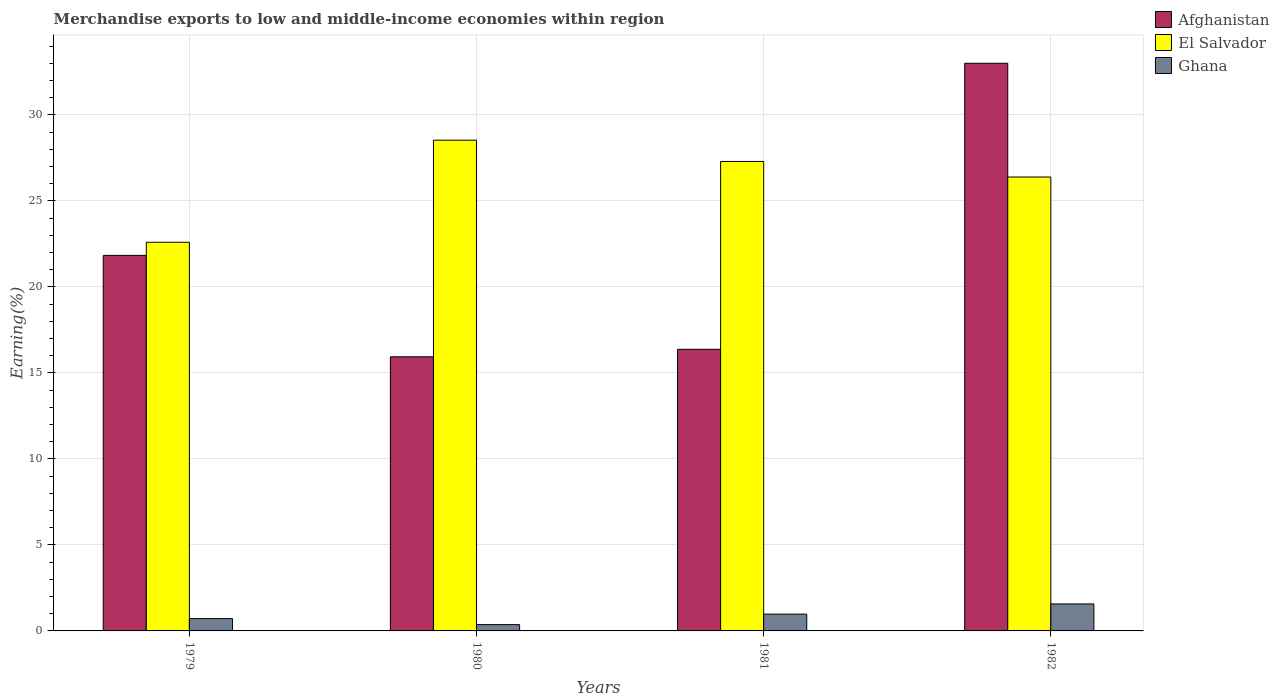Are the number of bars on each tick of the X-axis equal?
Ensure brevity in your answer.  Yes. How many bars are there on the 1st tick from the left?
Provide a succinct answer. 3. How many bars are there on the 4th tick from the right?
Your response must be concise. 3. What is the label of the 1st group of bars from the left?
Keep it short and to the point. 1979. In how many cases, is the number of bars for a given year not equal to the number of legend labels?
Your answer should be compact. 0. What is the percentage of amount earned from merchandise exports in Afghanistan in 1979?
Keep it short and to the point. 21.83. Across all years, what is the maximum percentage of amount earned from merchandise exports in El Salvador?
Make the answer very short. 28.53. Across all years, what is the minimum percentage of amount earned from merchandise exports in El Salvador?
Offer a very short reply. 22.59. In which year was the percentage of amount earned from merchandise exports in Afghanistan minimum?
Your answer should be compact. 1980. What is the total percentage of amount earned from merchandise exports in El Salvador in the graph?
Your answer should be very brief. 104.8. What is the difference between the percentage of amount earned from merchandise exports in Afghanistan in 1980 and that in 1981?
Give a very brief answer. -0.43. What is the difference between the percentage of amount earned from merchandise exports in El Salvador in 1981 and the percentage of amount earned from merchandise exports in Ghana in 1980?
Provide a succinct answer. 26.92. What is the average percentage of amount earned from merchandise exports in Ghana per year?
Offer a terse response. 0.91. In the year 1979, what is the difference between the percentage of amount earned from merchandise exports in El Salvador and percentage of amount earned from merchandise exports in Afghanistan?
Provide a short and direct response. 0.76. What is the ratio of the percentage of amount earned from merchandise exports in Ghana in 1980 to that in 1981?
Your answer should be compact. 0.38. Is the percentage of amount earned from merchandise exports in Afghanistan in 1979 less than that in 1980?
Your answer should be compact. No. What is the difference between the highest and the second highest percentage of amount earned from merchandise exports in El Salvador?
Your answer should be very brief. 1.24. What is the difference between the highest and the lowest percentage of amount earned from merchandise exports in Afghanistan?
Your answer should be very brief. 17.06. In how many years, is the percentage of amount earned from merchandise exports in Ghana greater than the average percentage of amount earned from merchandise exports in Ghana taken over all years?
Make the answer very short. 2. Is the sum of the percentage of amount earned from merchandise exports in Afghanistan in 1980 and 1982 greater than the maximum percentage of amount earned from merchandise exports in Ghana across all years?
Your answer should be very brief. Yes. What does the 2nd bar from the left in 1980 represents?
Ensure brevity in your answer.  El Salvador. What does the 3rd bar from the right in 1981 represents?
Your response must be concise. Afghanistan. What is the difference between two consecutive major ticks on the Y-axis?
Make the answer very short. 5. Does the graph contain any zero values?
Keep it short and to the point. No. Does the graph contain grids?
Give a very brief answer. Yes. How many legend labels are there?
Your response must be concise. 3. How are the legend labels stacked?
Your response must be concise. Vertical. What is the title of the graph?
Keep it short and to the point. Merchandise exports to low and middle-income economies within region. What is the label or title of the Y-axis?
Give a very brief answer. Earning(%). What is the Earning(%) of Afghanistan in 1979?
Offer a terse response. 21.83. What is the Earning(%) of El Salvador in 1979?
Provide a short and direct response. 22.59. What is the Earning(%) in Ghana in 1979?
Offer a very short reply. 0.72. What is the Earning(%) in Afghanistan in 1980?
Your answer should be compact. 15.94. What is the Earning(%) of El Salvador in 1980?
Make the answer very short. 28.53. What is the Earning(%) in Ghana in 1980?
Give a very brief answer. 0.37. What is the Earning(%) in Afghanistan in 1981?
Keep it short and to the point. 16.37. What is the Earning(%) in El Salvador in 1981?
Your answer should be very brief. 27.29. What is the Earning(%) of Ghana in 1981?
Ensure brevity in your answer.  0.98. What is the Earning(%) of Afghanistan in 1982?
Give a very brief answer. 33. What is the Earning(%) in El Salvador in 1982?
Provide a succinct answer. 26.39. What is the Earning(%) in Ghana in 1982?
Provide a short and direct response. 1.57. Across all years, what is the maximum Earning(%) in Afghanistan?
Keep it short and to the point. 33. Across all years, what is the maximum Earning(%) of El Salvador?
Provide a succinct answer. 28.53. Across all years, what is the maximum Earning(%) in Ghana?
Your answer should be compact. 1.57. Across all years, what is the minimum Earning(%) of Afghanistan?
Your response must be concise. 15.94. Across all years, what is the minimum Earning(%) of El Salvador?
Ensure brevity in your answer.  22.59. Across all years, what is the minimum Earning(%) of Ghana?
Your response must be concise. 0.37. What is the total Earning(%) of Afghanistan in the graph?
Your response must be concise. 87.14. What is the total Earning(%) of El Salvador in the graph?
Offer a terse response. 104.8. What is the total Earning(%) in Ghana in the graph?
Your answer should be very brief. 3.63. What is the difference between the Earning(%) in Afghanistan in 1979 and that in 1980?
Provide a short and direct response. 5.9. What is the difference between the Earning(%) in El Salvador in 1979 and that in 1980?
Give a very brief answer. -5.93. What is the difference between the Earning(%) in Ghana in 1979 and that in 1980?
Your answer should be very brief. 0.35. What is the difference between the Earning(%) in Afghanistan in 1979 and that in 1981?
Your answer should be compact. 5.46. What is the difference between the Earning(%) in El Salvador in 1979 and that in 1981?
Your answer should be very brief. -4.7. What is the difference between the Earning(%) of Ghana in 1979 and that in 1981?
Offer a very short reply. -0.26. What is the difference between the Earning(%) in Afghanistan in 1979 and that in 1982?
Give a very brief answer. -11.17. What is the difference between the Earning(%) in El Salvador in 1979 and that in 1982?
Your answer should be very brief. -3.79. What is the difference between the Earning(%) of Ghana in 1979 and that in 1982?
Ensure brevity in your answer.  -0.85. What is the difference between the Earning(%) in Afghanistan in 1980 and that in 1981?
Make the answer very short. -0.43. What is the difference between the Earning(%) of El Salvador in 1980 and that in 1981?
Your response must be concise. 1.24. What is the difference between the Earning(%) in Ghana in 1980 and that in 1981?
Your response must be concise. -0.61. What is the difference between the Earning(%) in Afghanistan in 1980 and that in 1982?
Give a very brief answer. -17.06. What is the difference between the Earning(%) of El Salvador in 1980 and that in 1982?
Provide a succinct answer. 2.14. What is the difference between the Earning(%) of Ghana in 1980 and that in 1982?
Keep it short and to the point. -1.2. What is the difference between the Earning(%) of Afghanistan in 1981 and that in 1982?
Your response must be concise. -16.63. What is the difference between the Earning(%) of El Salvador in 1981 and that in 1982?
Make the answer very short. 0.9. What is the difference between the Earning(%) in Ghana in 1981 and that in 1982?
Keep it short and to the point. -0.59. What is the difference between the Earning(%) in Afghanistan in 1979 and the Earning(%) in El Salvador in 1980?
Offer a terse response. -6.7. What is the difference between the Earning(%) of Afghanistan in 1979 and the Earning(%) of Ghana in 1980?
Provide a succinct answer. 21.46. What is the difference between the Earning(%) in El Salvador in 1979 and the Earning(%) in Ghana in 1980?
Keep it short and to the point. 22.23. What is the difference between the Earning(%) in Afghanistan in 1979 and the Earning(%) in El Salvador in 1981?
Your response must be concise. -5.46. What is the difference between the Earning(%) of Afghanistan in 1979 and the Earning(%) of Ghana in 1981?
Provide a succinct answer. 20.85. What is the difference between the Earning(%) in El Salvador in 1979 and the Earning(%) in Ghana in 1981?
Your answer should be very brief. 21.62. What is the difference between the Earning(%) of Afghanistan in 1979 and the Earning(%) of El Salvador in 1982?
Make the answer very short. -4.56. What is the difference between the Earning(%) in Afghanistan in 1979 and the Earning(%) in Ghana in 1982?
Offer a terse response. 20.26. What is the difference between the Earning(%) in El Salvador in 1979 and the Earning(%) in Ghana in 1982?
Offer a very short reply. 21.03. What is the difference between the Earning(%) in Afghanistan in 1980 and the Earning(%) in El Salvador in 1981?
Your answer should be compact. -11.36. What is the difference between the Earning(%) in Afghanistan in 1980 and the Earning(%) in Ghana in 1981?
Provide a succinct answer. 14.96. What is the difference between the Earning(%) in El Salvador in 1980 and the Earning(%) in Ghana in 1981?
Offer a terse response. 27.55. What is the difference between the Earning(%) in Afghanistan in 1980 and the Earning(%) in El Salvador in 1982?
Offer a very short reply. -10.45. What is the difference between the Earning(%) in Afghanistan in 1980 and the Earning(%) in Ghana in 1982?
Keep it short and to the point. 14.37. What is the difference between the Earning(%) in El Salvador in 1980 and the Earning(%) in Ghana in 1982?
Offer a very short reply. 26.96. What is the difference between the Earning(%) in Afghanistan in 1981 and the Earning(%) in El Salvador in 1982?
Keep it short and to the point. -10.02. What is the difference between the Earning(%) of Afghanistan in 1981 and the Earning(%) of Ghana in 1982?
Keep it short and to the point. 14.8. What is the difference between the Earning(%) in El Salvador in 1981 and the Earning(%) in Ghana in 1982?
Your response must be concise. 25.72. What is the average Earning(%) in Afghanistan per year?
Give a very brief answer. 21.78. What is the average Earning(%) in El Salvador per year?
Your response must be concise. 26.2. What is the average Earning(%) of Ghana per year?
Offer a terse response. 0.91. In the year 1979, what is the difference between the Earning(%) of Afghanistan and Earning(%) of El Salvador?
Your response must be concise. -0.76. In the year 1979, what is the difference between the Earning(%) in Afghanistan and Earning(%) in Ghana?
Make the answer very short. 21.11. In the year 1979, what is the difference between the Earning(%) in El Salvador and Earning(%) in Ghana?
Provide a short and direct response. 21.88. In the year 1980, what is the difference between the Earning(%) in Afghanistan and Earning(%) in El Salvador?
Keep it short and to the point. -12.59. In the year 1980, what is the difference between the Earning(%) of Afghanistan and Earning(%) of Ghana?
Offer a terse response. 15.57. In the year 1980, what is the difference between the Earning(%) of El Salvador and Earning(%) of Ghana?
Make the answer very short. 28.16. In the year 1981, what is the difference between the Earning(%) in Afghanistan and Earning(%) in El Salvador?
Your answer should be very brief. -10.92. In the year 1981, what is the difference between the Earning(%) in Afghanistan and Earning(%) in Ghana?
Make the answer very short. 15.39. In the year 1981, what is the difference between the Earning(%) in El Salvador and Earning(%) in Ghana?
Make the answer very short. 26.32. In the year 1982, what is the difference between the Earning(%) in Afghanistan and Earning(%) in El Salvador?
Offer a very short reply. 6.61. In the year 1982, what is the difference between the Earning(%) of Afghanistan and Earning(%) of Ghana?
Your answer should be very brief. 31.43. In the year 1982, what is the difference between the Earning(%) of El Salvador and Earning(%) of Ghana?
Ensure brevity in your answer.  24.82. What is the ratio of the Earning(%) of Afghanistan in 1979 to that in 1980?
Offer a very short reply. 1.37. What is the ratio of the Earning(%) of El Salvador in 1979 to that in 1980?
Ensure brevity in your answer.  0.79. What is the ratio of the Earning(%) in Ghana in 1979 to that in 1980?
Your answer should be very brief. 1.96. What is the ratio of the Earning(%) of Afghanistan in 1979 to that in 1981?
Ensure brevity in your answer.  1.33. What is the ratio of the Earning(%) of El Salvador in 1979 to that in 1981?
Your response must be concise. 0.83. What is the ratio of the Earning(%) in Ghana in 1979 to that in 1981?
Your response must be concise. 0.73. What is the ratio of the Earning(%) of Afghanistan in 1979 to that in 1982?
Give a very brief answer. 0.66. What is the ratio of the Earning(%) of El Salvador in 1979 to that in 1982?
Provide a short and direct response. 0.86. What is the ratio of the Earning(%) in Ghana in 1979 to that in 1982?
Give a very brief answer. 0.46. What is the ratio of the Earning(%) of Afghanistan in 1980 to that in 1981?
Offer a terse response. 0.97. What is the ratio of the Earning(%) of El Salvador in 1980 to that in 1981?
Keep it short and to the point. 1.05. What is the ratio of the Earning(%) in Ghana in 1980 to that in 1981?
Give a very brief answer. 0.38. What is the ratio of the Earning(%) of Afghanistan in 1980 to that in 1982?
Your answer should be very brief. 0.48. What is the ratio of the Earning(%) of El Salvador in 1980 to that in 1982?
Keep it short and to the point. 1.08. What is the ratio of the Earning(%) in Ghana in 1980 to that in 1982?
Keep it short and to the point. 0.23. What is the ratio of the Earning(%) in Afghanistan in 1981 to that in 1982?
Your answer should be very brief. 0.5. What is the ratio of the Earning(%) of El Salvador in 1981 to that in 1982?
Your answer should be compact. 1.03. What is the ratio of the Earning(%) of Ghana in 1981 to that in 1982?
Your response must be concise. 0.62. What is the difference between the highest and the second highest Earning(%) of Afghanistan?
Keep it short and to the point. 11.17. What is the difference between the highest and the second highest Earning(%) of El Salvador?
Your answer should be very brief. 1.24. What is the difference between the highest and the second highest Earning(%) of Ghana?
Your response must be concise. 0.59. What is the difference between the highest and the lowest Earning(%) of Afghanistan?
Offer a very short reply. 17.06. What is the difference between the highest and the lowest Earning(%) in El Salvador?
Provide a short and direct response. 5.93. What is the difference between the highest and the lowest Earning(%) of Ghana?
Your response must be concise. 1.2. 